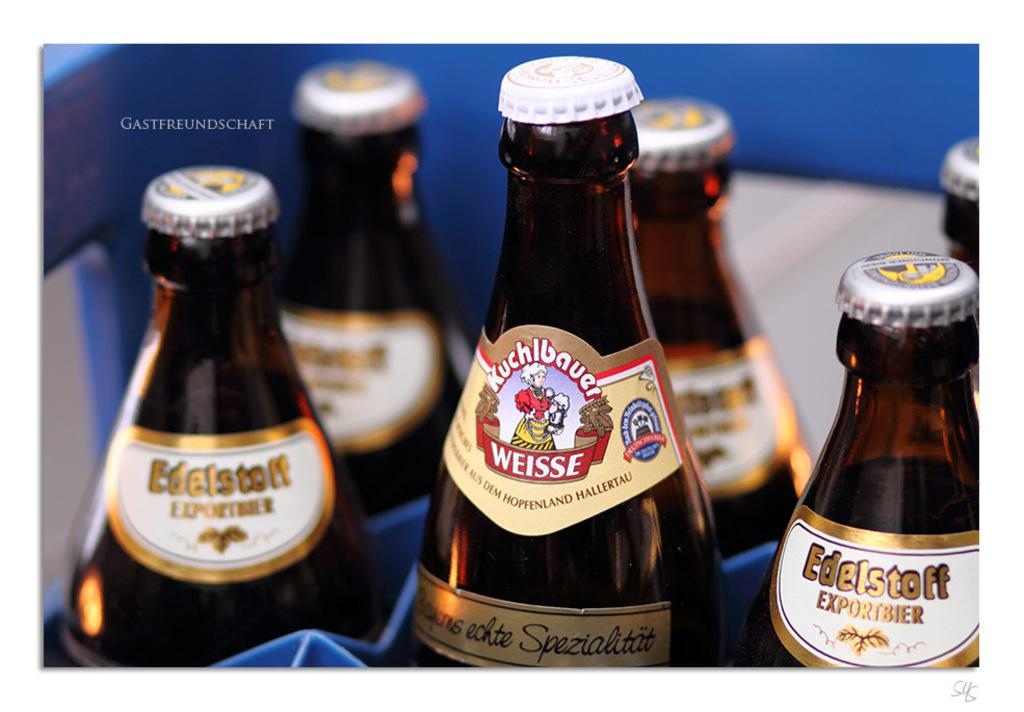Provide a one-sentence caption for the provided image. A group of imported beer bottles include a Weisse. 